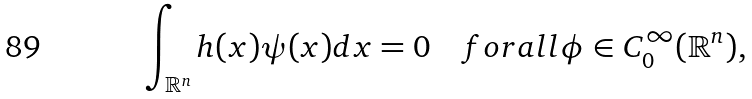Convert formula to latex. <formula><loc_0><loc_0><loc_500><loc_500>\int _ { \mathbb { R } ^ { n } } h ( x ) \psi ( x ) d x = 0 \quad f o r a l l \phi \in C _ { 0 } ^ { \infty } ( \mathbb { R } ^ { n } ) ,</formula> 